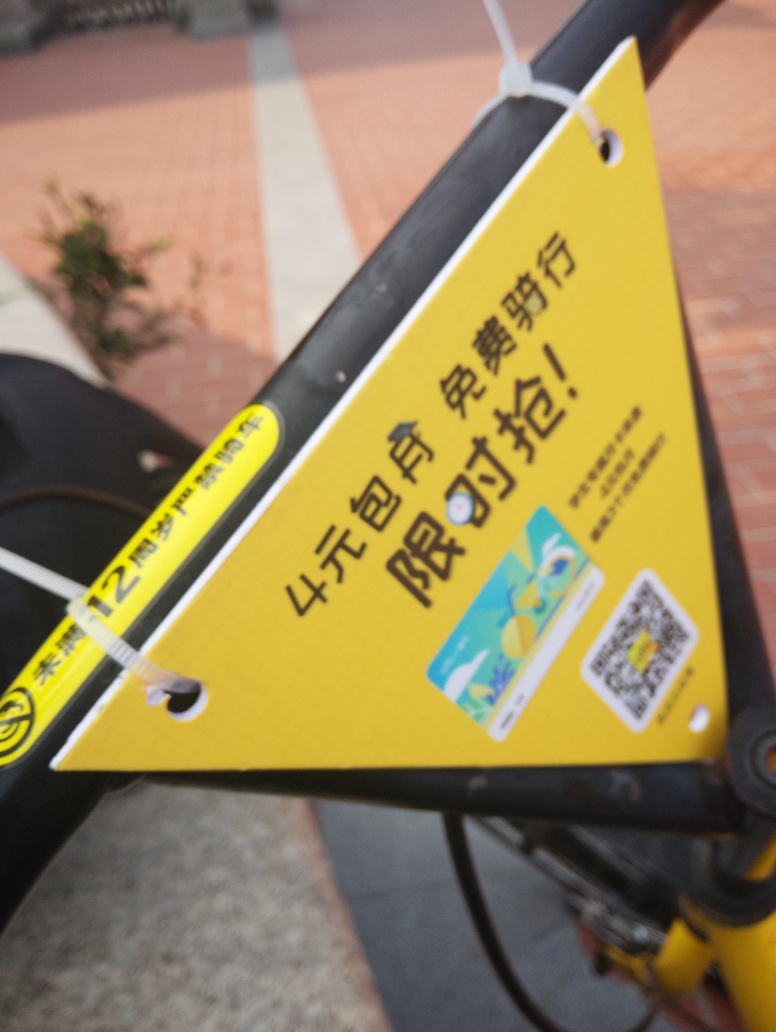Can you describe what's on the card in the image? The card appears to be yellow with some printed text and graphics, possibly serving as an informational sign or label, potentially containing instructions or promotional content. However, due to the blur, specific details such as text and the QR code are not clear enough to be read or scanned. 